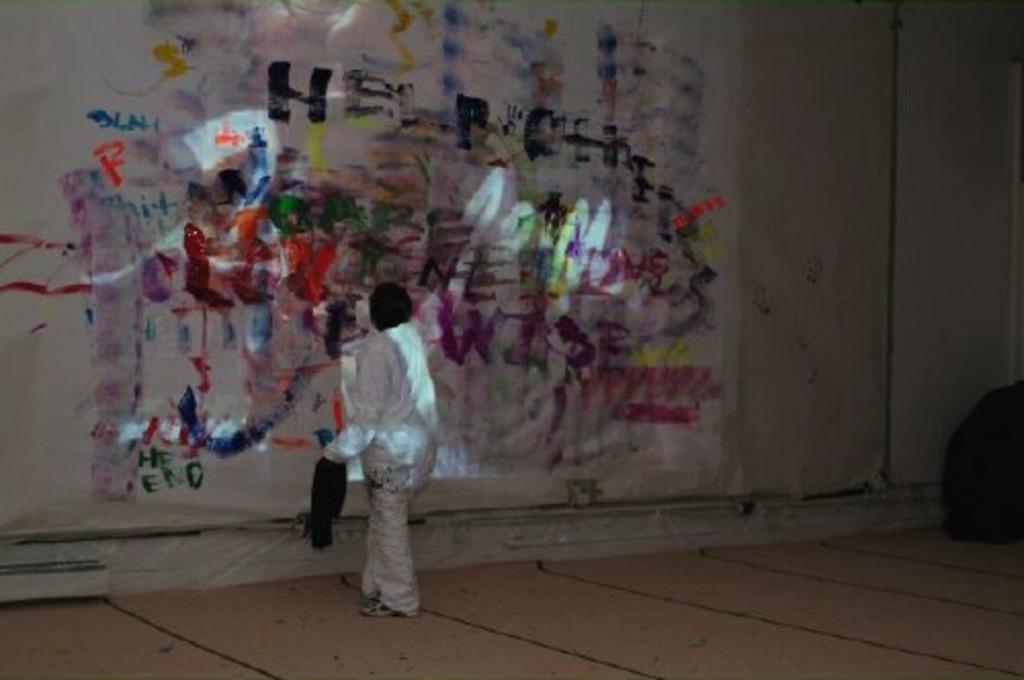Please provide a concise description of this image. This picture might be taken inside a room. In this image, in the middle, we can see a person wearing a white color dress. In the background, we can see a wall with some paintings. 